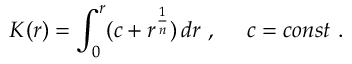Convert formula to latex. <formula><loc_0><loc_0><loc_500><loc_500>K ( r ) = \int _ { 0 } ^ { r } ( c + r ^ { \frac { 1 } { n } } ) \, d r \ , \quad c = c o n s t \ .</formula> 